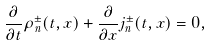<formula> <loc_0><loc_0><loc_500><loc_500>\frac { \partial } { \partial t } \rho ^ { \pm } _ { n } ( t , x ) + \frac { \partial } { \partial x } j ^ { \pm } _ { n } ( t , x ) = 0 ,</formula> 